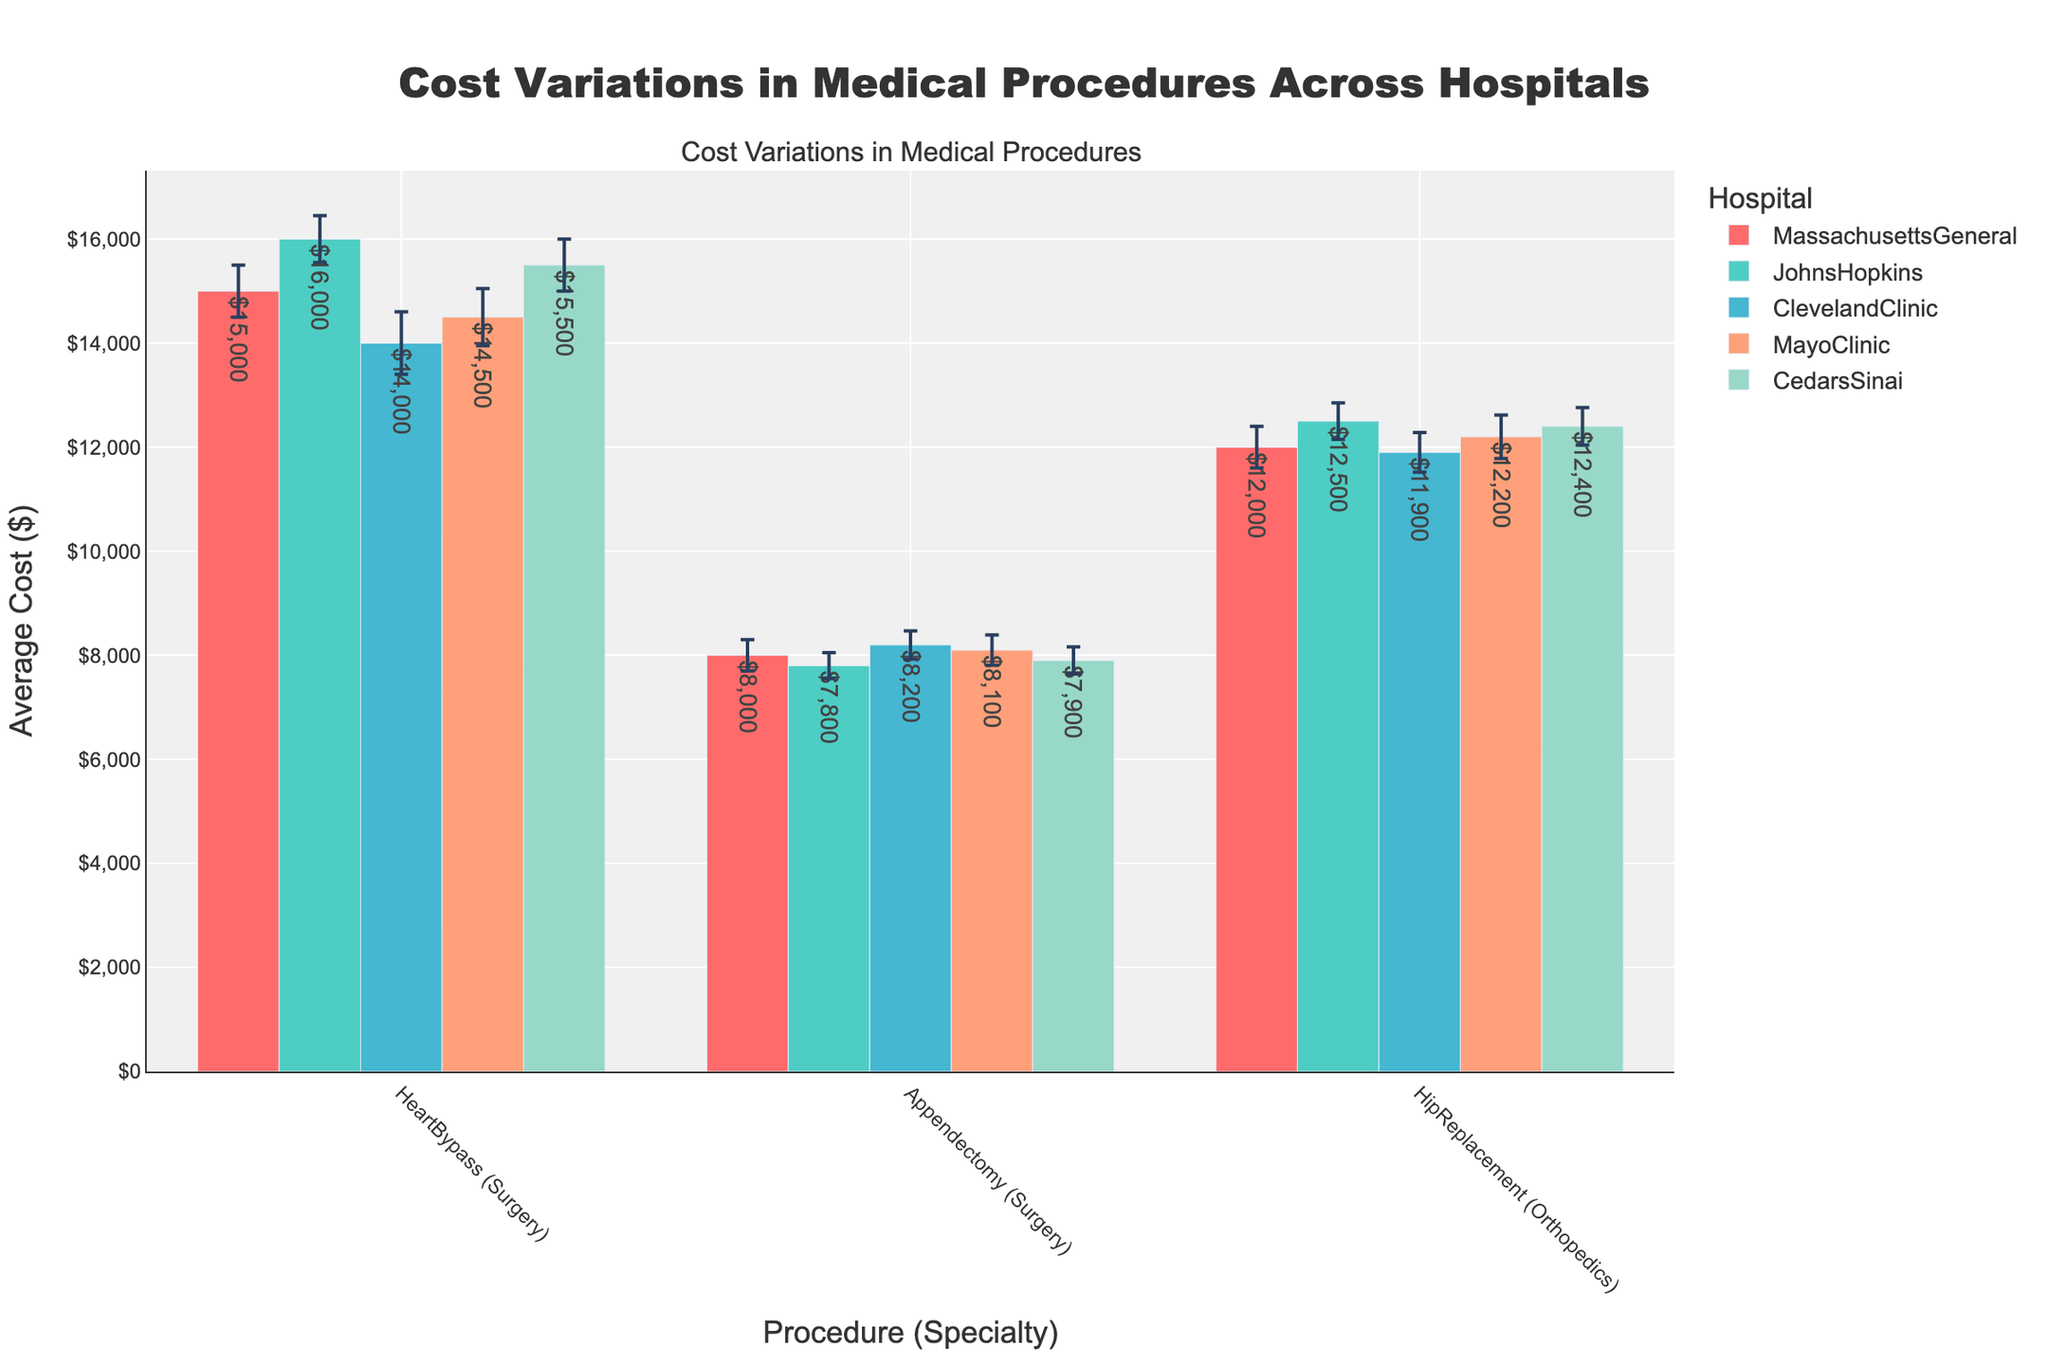What is the title of the plot? The title of the plot is usually displayed at the top of the figure. In this case, it states the main subject of the plot, which is the variation in medical procedure costs across different hospitals.
Answer: Cost Variations in Medical Procedures Across Hospitals How many hospitals are compared in the plot? Each hospital is represented by a different color group in the bar chart. By counting the distinct groups, you can determine the number of hospitals.
Answer: 5 Which hospital shows the highest average cost for the Heart Bypass procedure? You can identify the highest bar within the Heart Bypass procedure section and check its corresponding hospital.
Answer: Johns Hopkins What is the average cost range (highest to lowest) for the Appendectomy procedure across all hospitals? To find the range, identify the highest and lowest bars within the Appendectomy section and subtract the lowest value from the highest.
Answer: Range: $8200 (Cleveland Clinic) - $7800 (Johns Hopkins) = $400 What is the difference between the highest and lowest average cost for the Hip Replacement procedure? Identify the bars for the Hip Replacement procedure, note the highest average cost and the lowest average cost, then subtract the lower from the higher.
Answer: $12500 (Johns Hopkins) - $11900 (Cleveland Clinic) = $600 Which procedure has the largest error margin across all hospitals? Review the error bars for each procedure and find the one with the longest error bar.
Answer: Heart Bypass (Cleveland Clinic) How does the average cost for the Heart Bypass procedure at Massachusetts General compare to the same procedure at Mayo Clinic? Identify the average cost for the Heart Bypass procedure at both Massachusetts General and Mayo Clinic and compare the values.
Answer: Massachusetts General: $15000; Mayo Clinic: $14500 Which procedure and specialty combination show the smallest variation in cost among all hospitals? Look at the error bars across all combinations, and the one with the smallest overall error margins indicates the smallest variation.
Answer: Appendectomy (Surgery) How does the cost for Hip Replacement at Cedars-Sinai compare to the average of the costs at all other hospitals for the same procedure? Identify the cost for Hip Replacement at Cedars-Sinai, then calculate the average cost of the remaining hospitals for Hip Replacement and compare the two.
Answer: Cedars-Sinai: $12400; Average of others: ($12000 + $12500 + $11900 + $12200) / 4 = $12150 What can you infer from the variation in error margins for the Heart Bypass procedure across different hospitals? Compare the length of the error bars for the Heart Bypass procedure at all hospitals and note any significant differences, which might suggest differences in cost predictability or reliability.
Answer: Cleveland Clinic has the largest error margin, indicating more variability in cost estimates there compared to other hospitals 